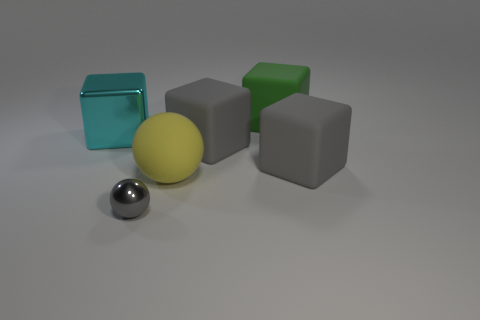Subtract all green cubes. How many cubes are left? 3 Subtract all large matte blocks. How many blocks are left? 1 Subtract all purple blocks. Subtract all yellow balls. How many blocks are left? 4 Add 2 shiny spheres. How many objects exist? 8 Subtract all balls. How many objects are left? 4 Subtract all big gray blocks. Subtract all gray shiny things. How many objects are left? 3 Add 3 yellow spheres. How many yellow spheres are left? 4 Add 3 matte things. How many matte things exist? 7 Subtract 0 brown balls. How many objects are left? 6 